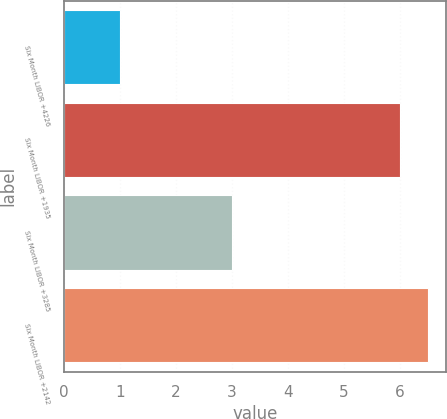Convert chart to OTSL. <chart><loc_0><loc_0><loc_500><loc_500><bar_chart><fcel>Six Month LIBOR +4226<fcel>Six Month LIBOR +1935<fcel>Six Month LIBOR +3285<fcel>Six Month LIBOR +2142<nl><fcel>1<fcel>6<fcel>3<fcel>6.5<nl></chart> 